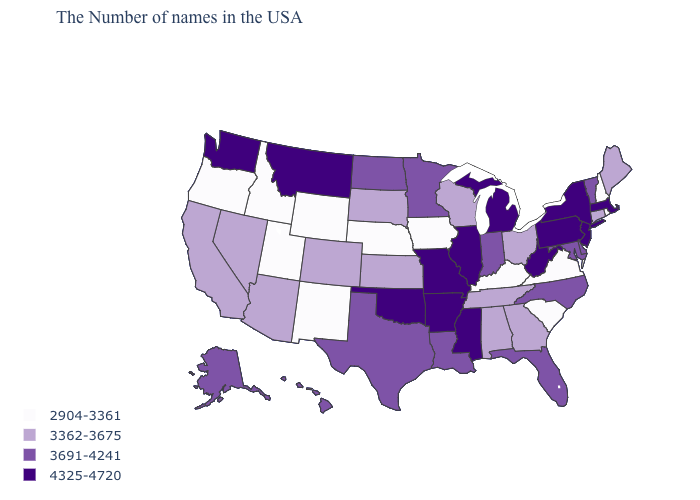What is the value of Virginia?
Answer briefly. 2904-3361. Which states hav the highest value in the MidWest?
Be succinct. Michigan, Illinois, Missouri. What is the value of Georgia?
Short answer required. 3362-3675. Which states have the lowest value in the USA?
Be succinct. Rhode Island, New Hampshire, Virginia, South Carolina, Kentucky, Iowa, Nebraska, Wyoming, New Mexico, Utah, Idaho, Oregon. What is the value of New York?
Write a very short answer. 4325-4720. Which states hav the highest value in the Northeast?
Write a very short answer. Massachusetts, New York, New Jersey, Pennsylvania. What is the value of Montana?
Short answer required. 4325-4720. Does Alabama have the lowest value in the South?
Write a very short answer. No. Does the map have missing data?
Answer briefly. No. What is the lowest value in the MidWest?
Keep it brief. 2904-3361. Does Delaware have the same value as North Dakota?
Quick response, please. Yes. Name the states that have a value in the range 3691-4241?
Answer briefly. Vermont, Delaware, Maryland, North Carolina, Florida, Indiana, Louisiana, Minnesota, Texas, North Dakota, Alaska, Hawaii. Which states have the highest value in the USA?
Concise answer only. Massachusetts, New York, New Jersey, Pennsylvania, West Virginia, Michigan, Illinois, Mississippi, Missouri, Arkansas, Oklahoma, Montana, Washington. What is the value of Wisconsin?
Concise answer only. 3362-3675. 